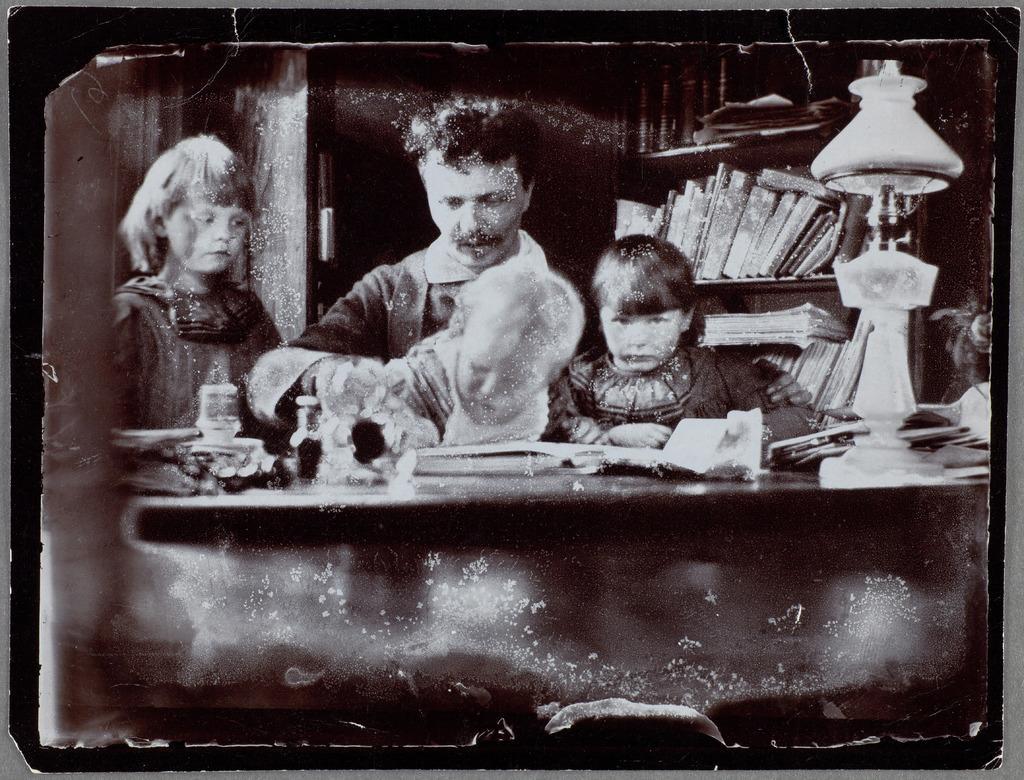How would you summarize this image in a sentence or two? In the image we can see an old photograph, in it we can see a man and three children wearing clothes. Here we can see the lamp and there are books kept on the shelves. 